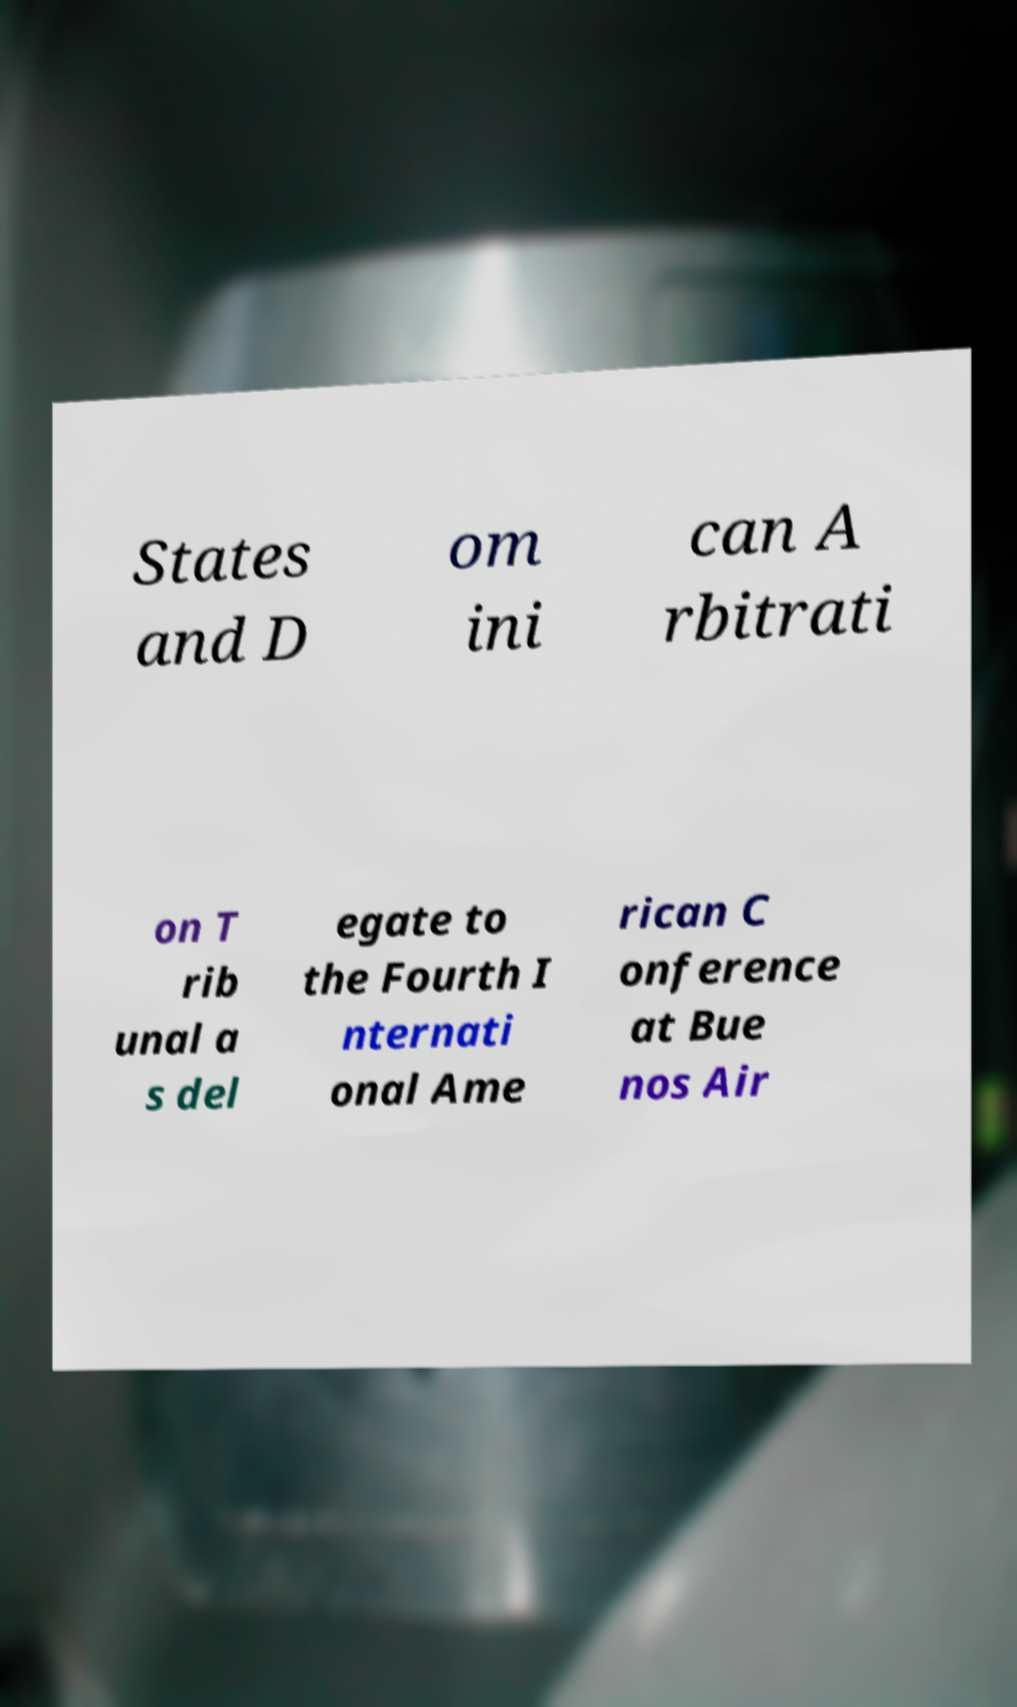Could you assist in decoding the text presented in this image and type it out clearly? States and D om ini can A rbitrati on T rib unal a s del egate to the Fourth I nternati onal Ame rican C onference at Bue nos Air 